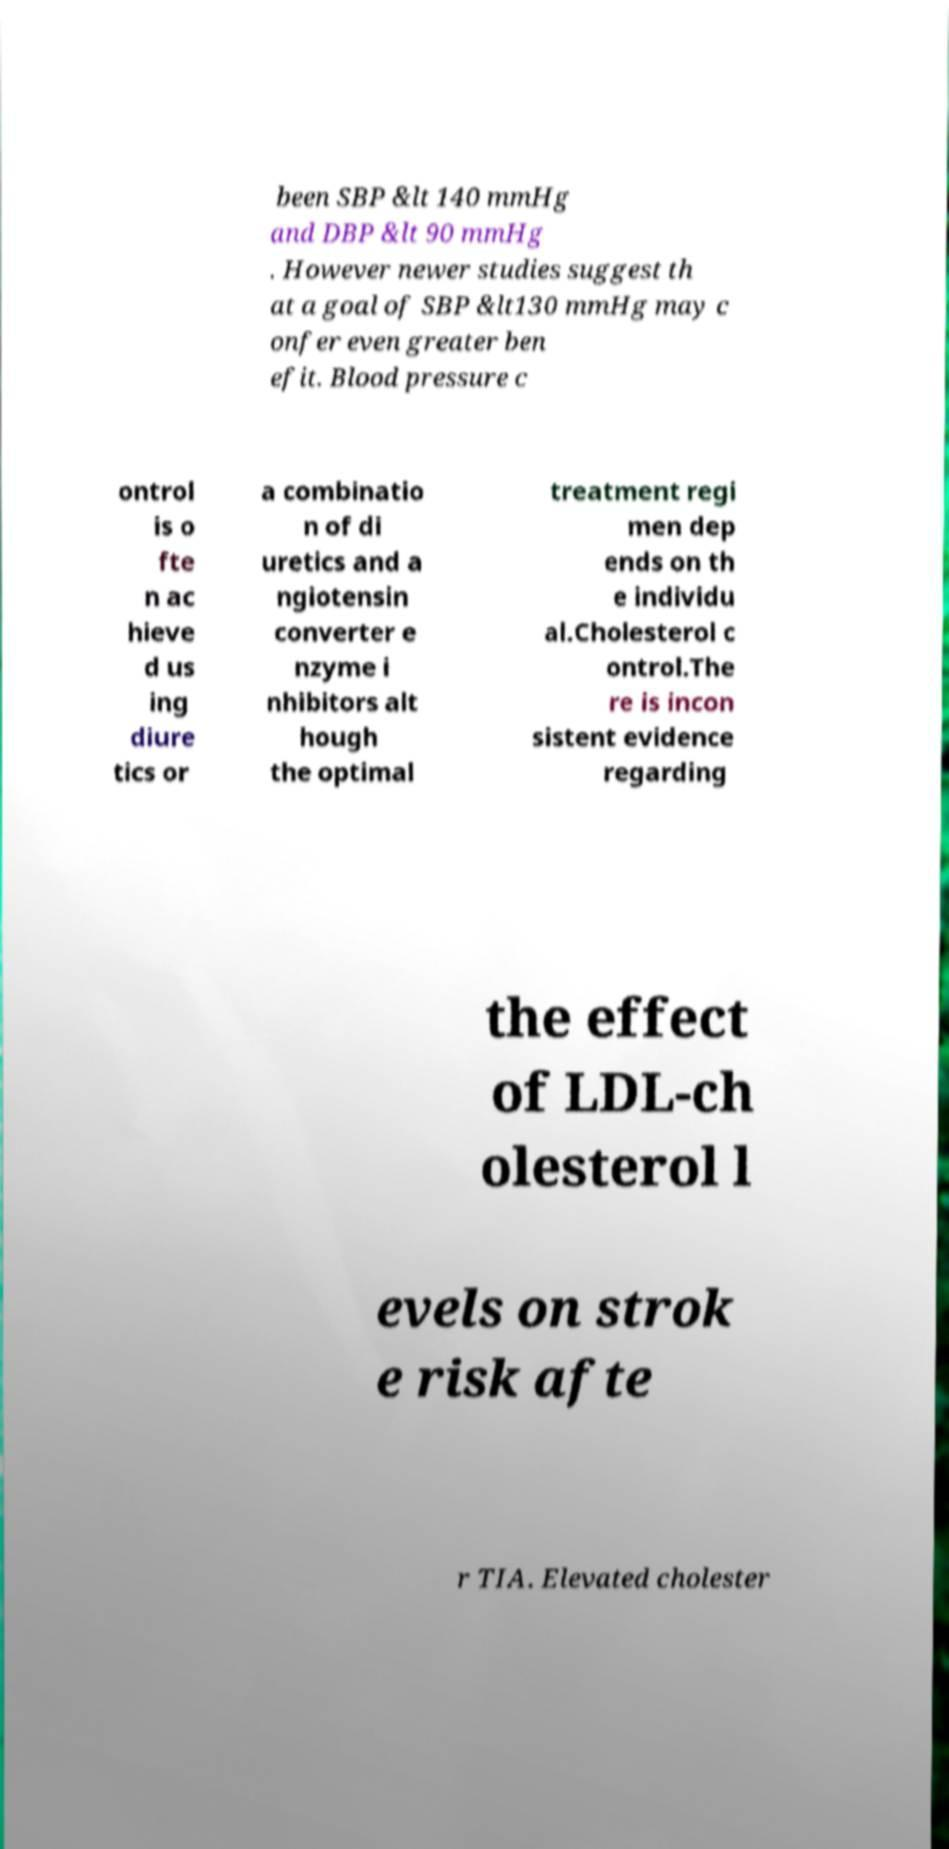I need the written content from this picture converted into text. Can you do that? been SBP &lt 140 mmHg and DBP &lt 90 mmHg . However newer studies suggest th at a goal of SBP &lt130 mmHg may c onfer even greater ben efit. Blood pressure c ontrol is o fte n ac hieve d us ing diure tics or a combinatio n of di uretics and a ngiotensin converter e nzyme i nhibitors alt hough the optimal treatment regi men dep ends on th e individu al.Cholesterol c ontrol.The re is incon sistent evidence regarding the effect of LDL-ch olesterol l evels on strok e risk afte r TIA. Elevated cholester 